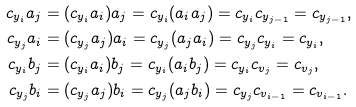<formula> <loc_0><loc_0><loc_500><loc_500>c _ { y _ { i } } a _ { j } & = ( c _ { y _ { i } } a _ { i } ) a _ { j } = c _ { y _ { i } } ( a _ { i } a _ { j } ) = c _ { y _ { i } } c _ { y _ { j - 1 } } = c _ { y _ { j - 1 } } , \\ c _ { y _ { j } } a _ { i } & = ( c _ { y _ { j } } a _ { j } ) a _ { i } = c _ { y _ { j } } ( a _ { j } a _ { i } ) = c _ { y _ { j } } c _ { y _ { i } } = c _ { y _ { i } } , \\ c _ { y _ { i } } b _ { j } & = ( c _ { y _ { i } } a _ { i } ) b _ { j } = c _ { y _ { i } } ( a _ { i } b _ { j } ) = c _ { y _ { i } } c _ { v _ { j } } = c _ { v _ { j } } , \\ c _ { y _ { j } } b _ { i } & = ( c _ { y _ { j } } a _ { j } ) b _ { i } = c _ { y _ { j } } ( a _ { j } b _ { i } ) = c _ { y _ { j } } c _ { v _ { i - 1 } } = c _ { v _ { i - 1 } } .</formula> 